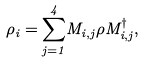Convert formula to latex. <formula><loc_0><loc_0><loc_500><loc_500>\rho _ { i } = \overset { 4 } { \underset { j = 1 } { \sum } } M _ { i , j } \rho M _ { i , j } ^ { \dagger } ,</formula> 